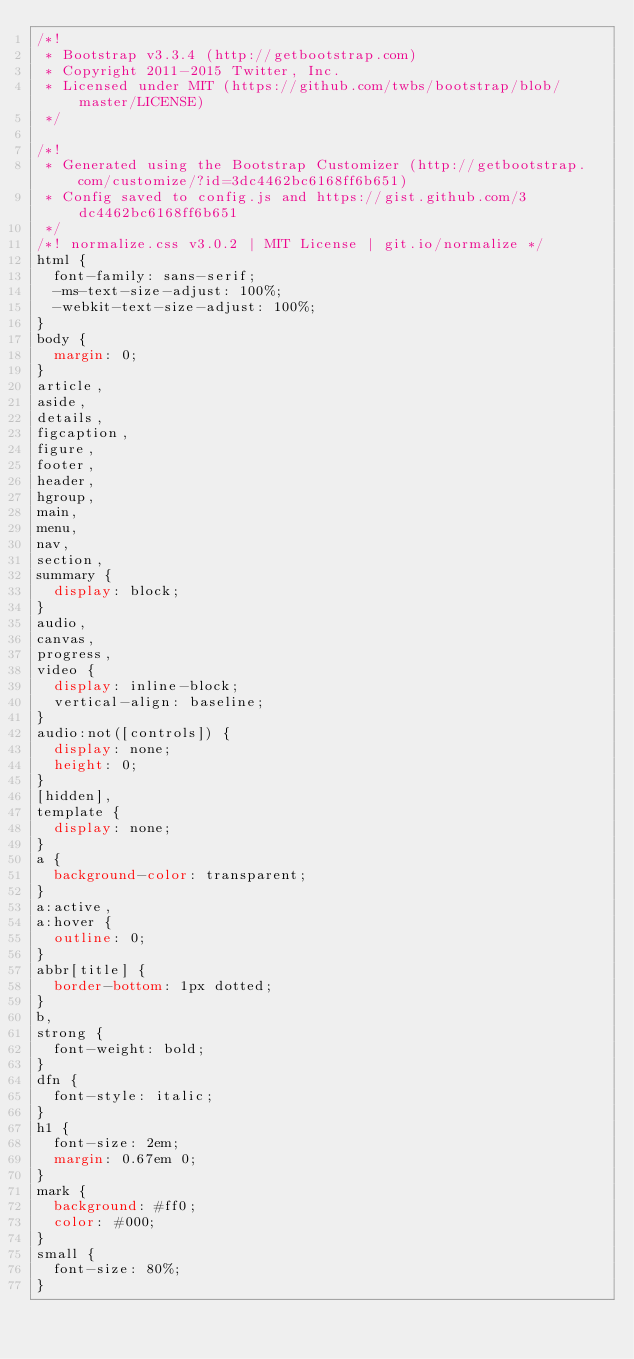Convert code to text. <code><loc_0><loc_0><loc_500><loc_500><_CSS_>/*!
 * Bootstrap v3.3.4 (http://getbootstrap.com)
 * Copyright 2011-2015 Twitter, Inc.
 * Licensed under MIT (https://github.com/twbs/bootstrap/blob/master/LICENSE)
 */

/*!
 * Generated using the Bootstrap Customizer (http://getbootstrap.com/customize/?id=3dc4462bc6168ff6b651)
 * Config saved to config.js and https://gist.github.com/3dc4462bc6168ff6b651
 */
/*! normalize.css v3.0.2 | MIT License | git.io/normalize */
html {
  font-family: sans-serif;
  -ms-text-size-adjust: 100%;
  -webkit-text-size-adjust: 100%;
}
body {
  margin: 0;
}
article,
aside,
details,
figcaption,
figure,
footer,
header,
hgroup,
main,
menu,
nav,
section,
summary {
  display: block;
}
audio,
canvas,
progress,
video {
  display: inline-block;
  vertical-align: baseline;
}
audio:not([controls]) {
  display: none;
  height: 0;
}
[hidden],
template {
  display: none;
}
a {
  background-color: transparent;
}
a:active,
a:hover {
  outline: 0;
}
abbr[title] {
  border-bottom: 1px dotted;
}
b,
strong {
  font-weight: bold;
}
dfn {
  font-style: italic;
}
h1 {
  font-size: 2em;
  margin: 0.67em 0;
}
mark {
  background: #ff0;
  color: #000;
}
small {
  font-size: 80%;
}</code> 